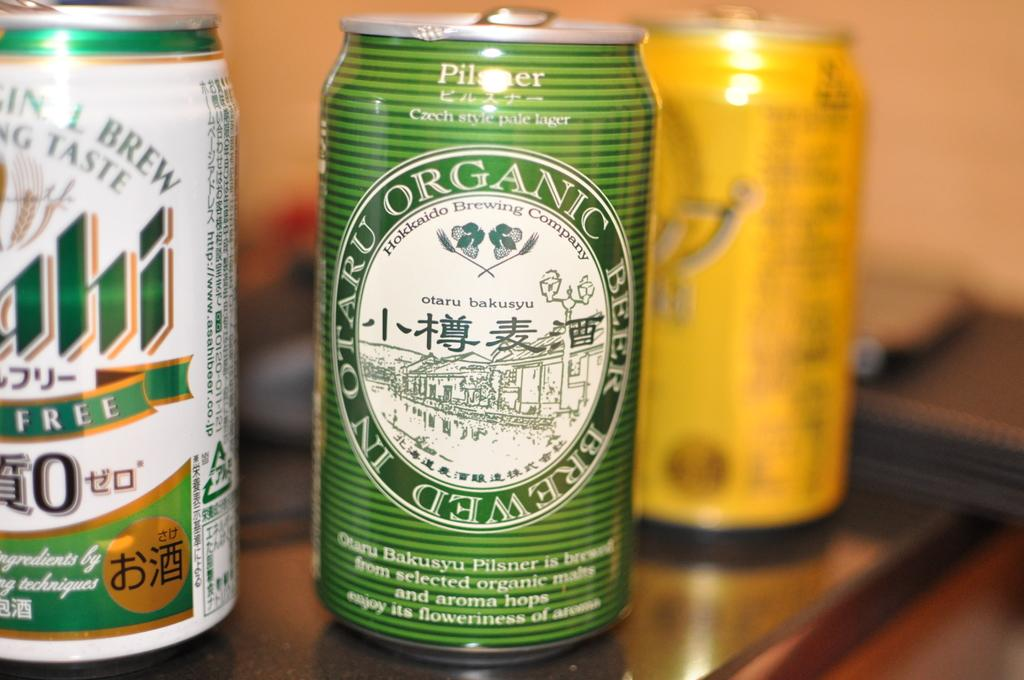How many tins are visible in the image? There are three tins in the image. Where are the tins located? The tins are on a platform. Can you describe the background of the image? The background of the image is blurred. What type of pollution can be seen in the image? There is no pollution visible in the image; it only features three tins on a platform with a blurred background. 